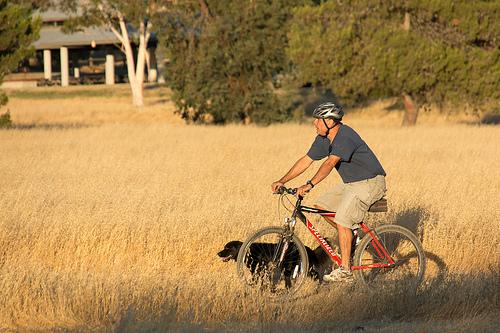Provide a short summary of the scene captured in this image. In this image, a man in casual clothing rides a red bike with his black dog, surrounded by a field and a forest of green trees. Mention the key figures in the image and their noteworthy features. There is a man in a gray shirt and a black helmet, riding a red bike, and a medium-sized black dog panting and walking by his side. Mention the most prominent action taking place in the image. A man wearing a helmet is riding a red bike alongside a black dog in a field of tall yellow grass. Identify the key elements in the image and their possible location. A man and a black dog are near the center of the image in a field, a dense group of green trees to their right, and a medium-sized picnic pavilion to their left. What are the significant elements of the image, and how do they interact with one another? A man wearing a blue shirt and brown shorts, rides a red bike with a silver and black helmet, accompanied by a black dog walking next to him in the field. Describe the environment and the atmosphere of the image. The image portrays a peaceful outdoor scene, where a man on a bike and his dog are enjoying a ride through a field with green trees, and a pavilion nearby. What are the main colors and objects featured in this image? The image shows a red and black bike, a silver and black helmet, a gray and black roof, a mans blue shirt, a tall gray tree branch, and a black dog. Describe the scenery and the main activity occurring in the image. A man on a bike with his black walking dog enjoy a leisurely ride in a field with tall grass, surrounded by green trees and a picnic pavilion. What are the primary actions of the man and the dog? The man is pedaling a red bike, wearing a helmet, while the black dog walks beside him, panting with its tongue out. Describe the man and the dog in the image and their relationship to one another. The man in a gray shirt and brown shorts is riding a red bike, while a medium-sized black dog walks beside him with tongue out. 